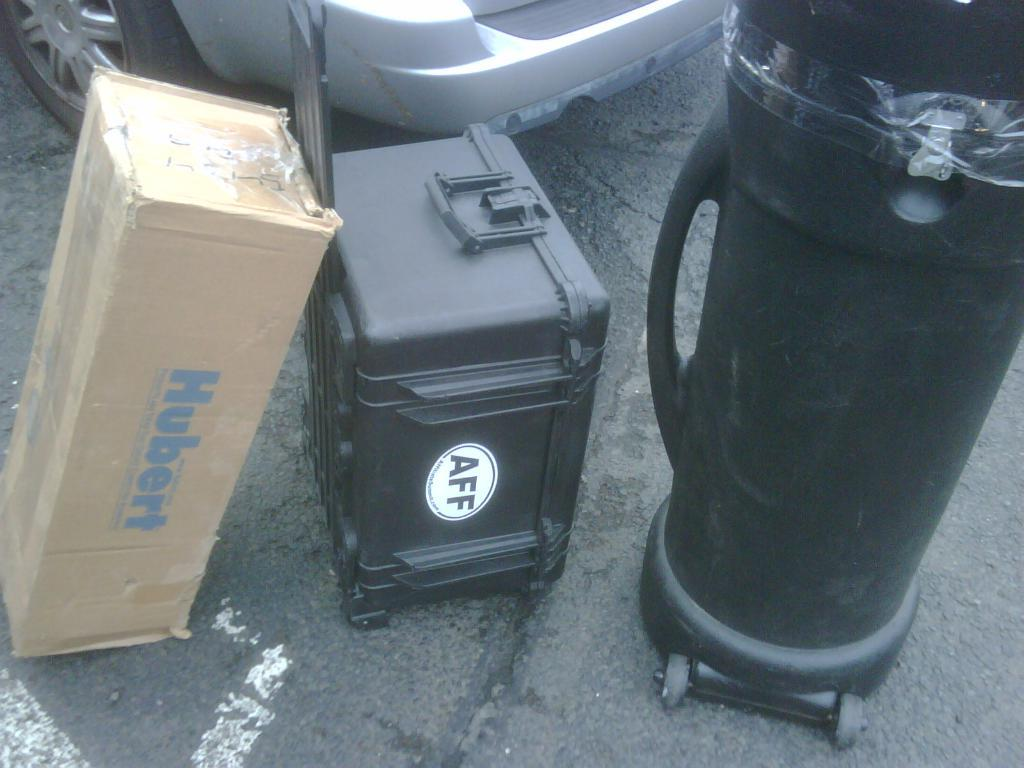<image>
Give a short and clear explanation of the subsequent image. Small black container with a white sticker that says AFF. 